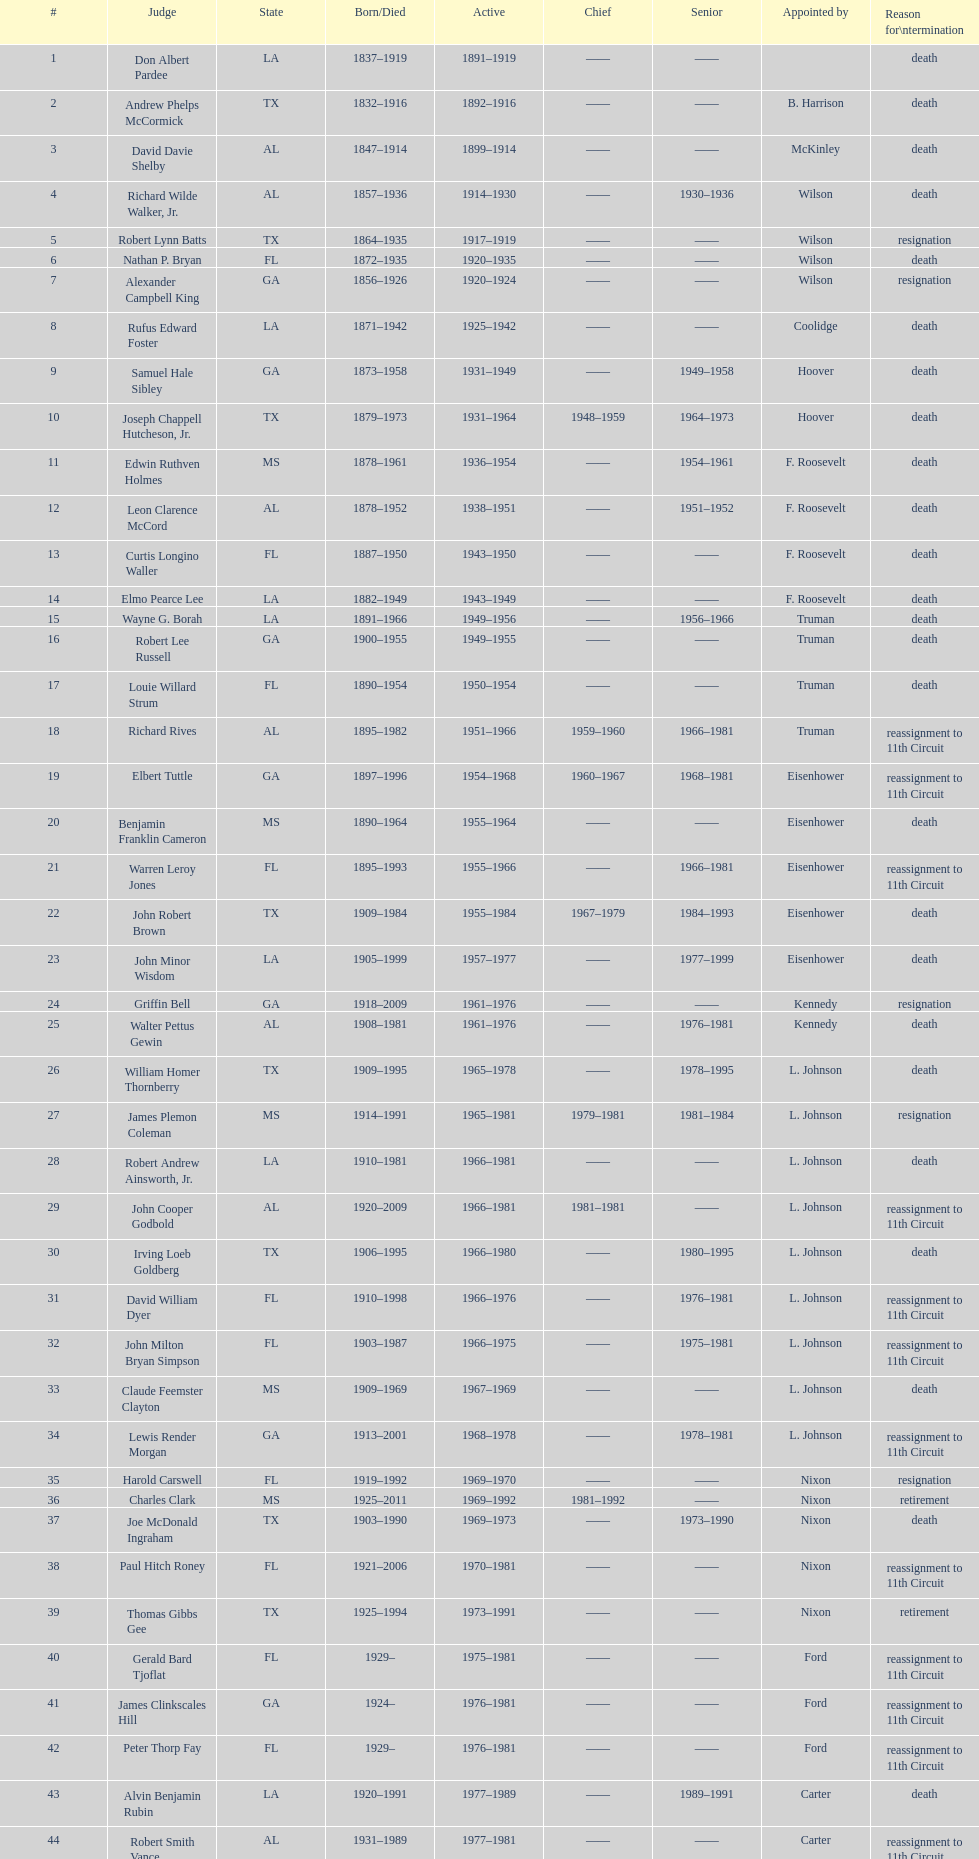What is a state that shows up on the list 4 or more times? TX. 